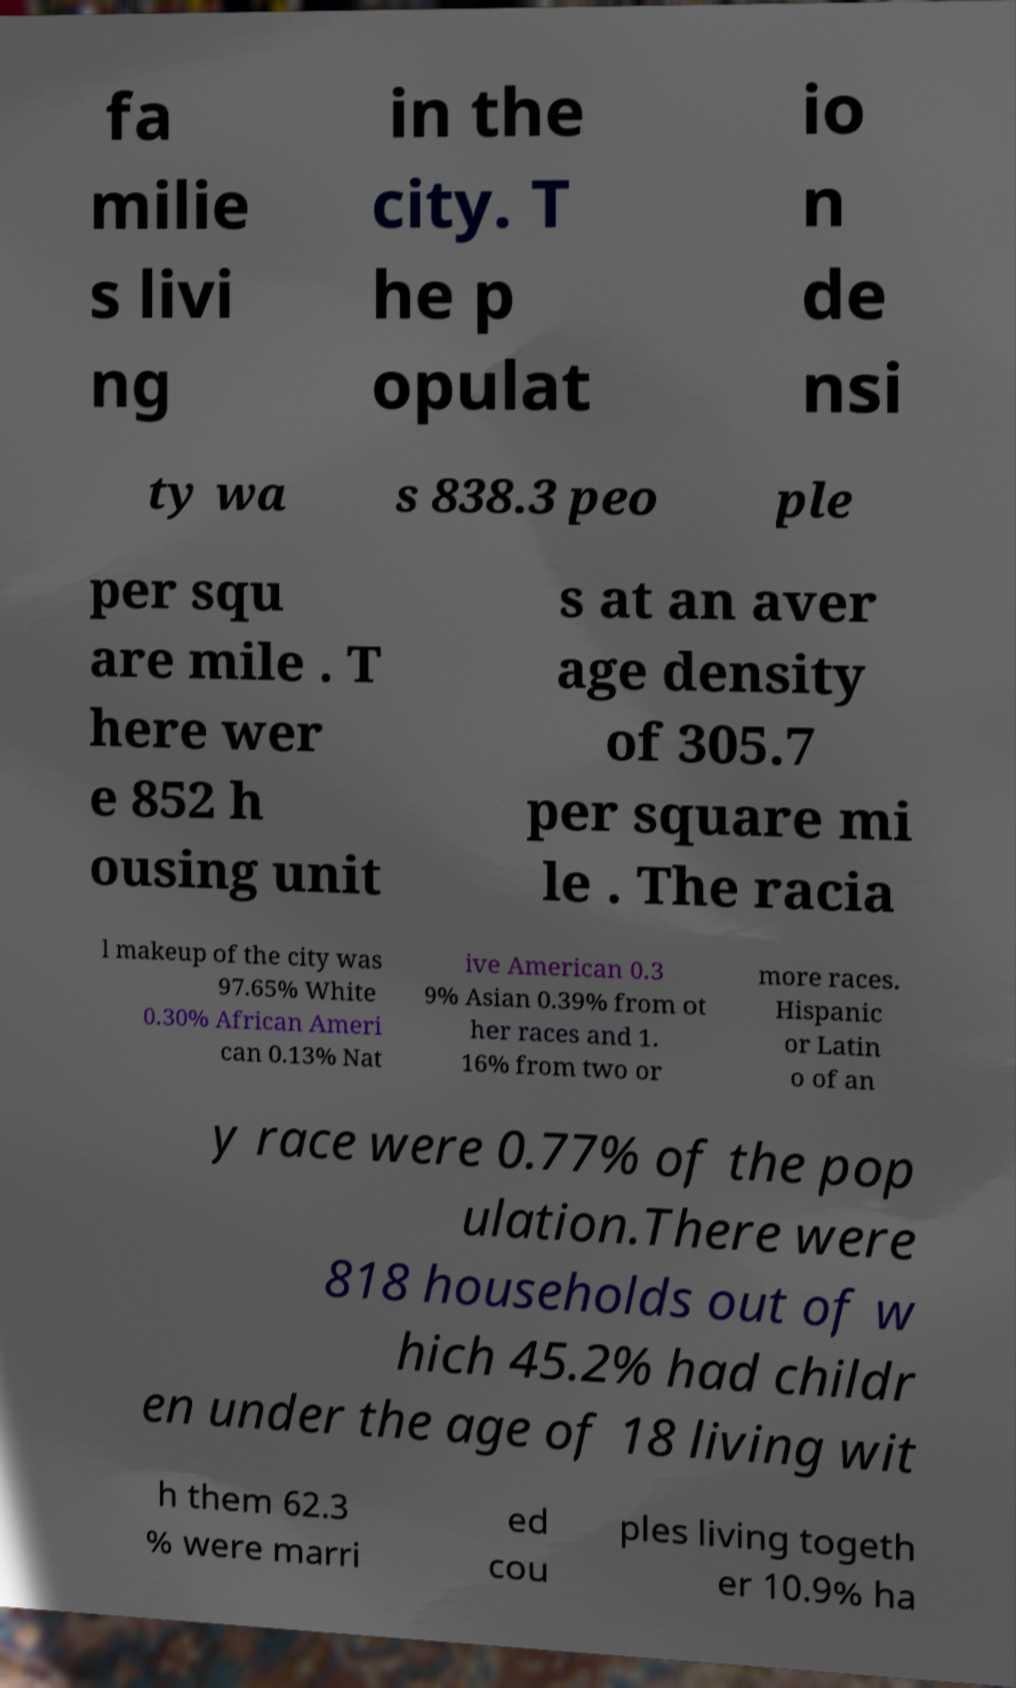There's text embedded in this image that I need extracted. Can you transcribe it verbatim? fa milie s livi ng in the city. T he p opulat io n de nsi ty wa s 838.3 peo ple per squ are mile . T here wer e 852 h ousing unit s at an aver age density of 305.7 per square mi le . The racia l makeup of the city was 97.65% White 0.30% African Ameri can 0.13% Nat ive American 0.3 9% Asian 0.39% from ot her races and 1. 16% from two or more races. Hispanic or Latin o of an y race were 0.77% of the pop ulation.There were 818 households out of w hich 45.2% had childr en under the age of 18 living wit h them 62.3 % were marri ed cou ples living togeth er 10.9% ha 